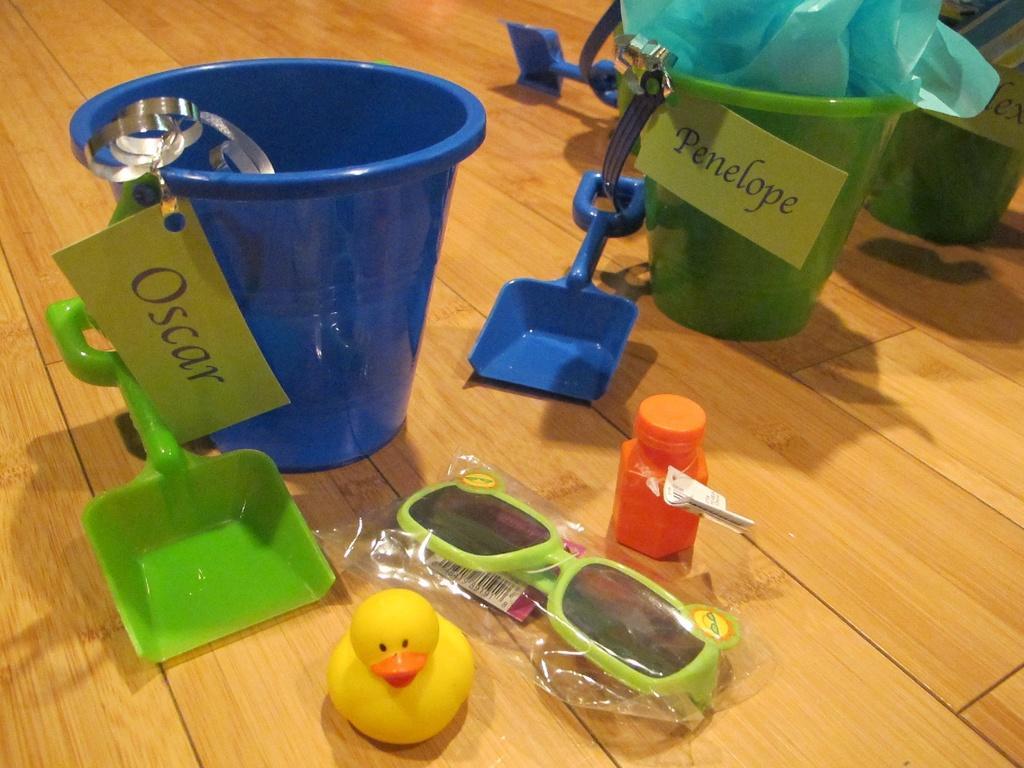How would you summarize this image in a sentence or two? In this image I can see a blue colour bucket and two green colour buckets. I can also see a three boards, a plastic in one bucket, a yellow colour toy duck, a green and black colour shades in the plastic cover, an orange colour bottle and three plastic shovels. I can also see something is written on these boards. 